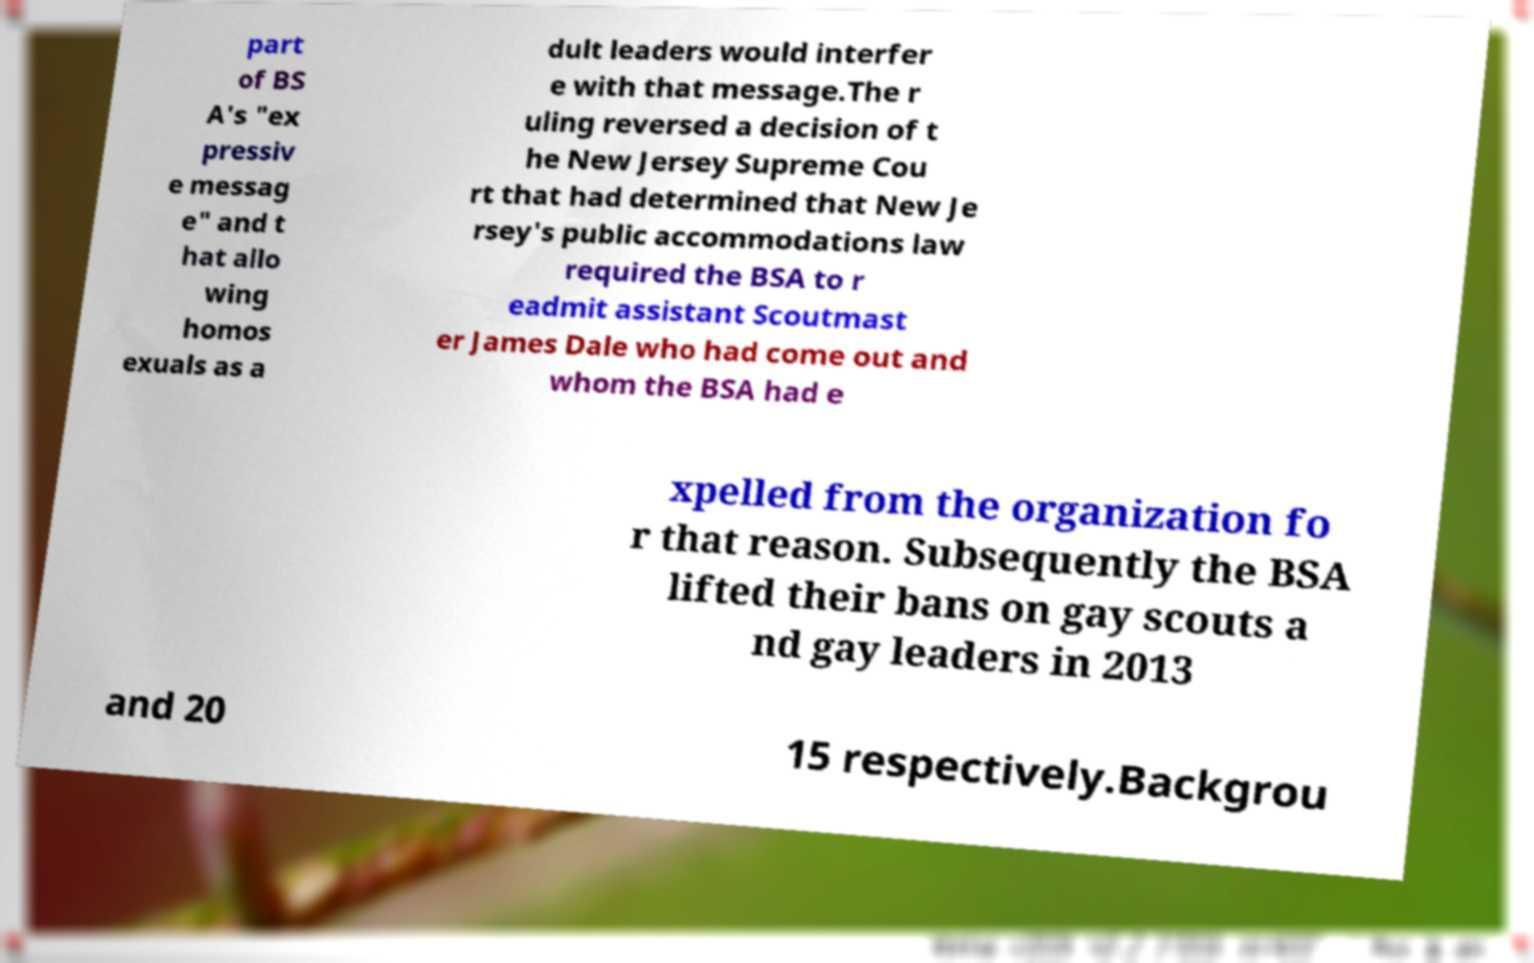For documentation purposes, I need the text within this image transcribed. Could you provide that? part of BS A's "ex pressiv e messag e" and t hat allo wing homos exuals as a dult leaders would interfer e with that message.The r uling reversed a decision of t he New Jersey Supreme Cou rt that had determined that New Je rsey's public accommodations law required the BSA to r eadmit assistant Scoutmast er James Dale who had come out and whom the BSA had e xpelled from the organization fo r that reason. Subsequently the BSA lifted their bans on gay scouts a nd gay leaders in 2013 and 20 15 respectively.Backgrou 